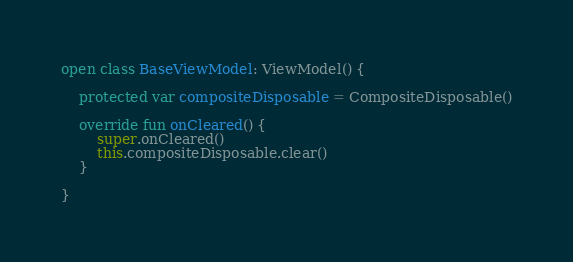Convert code to text. <code><loc_0><loc_0><loc_500><loc_500><_Kotlin_>open class BaseViewModel: ViewModel() {

    protected var compositeDisposable = CompositeDisposable()

    override fun onCleared() {
        super.onCleared()
        this.compositeDisposable.clear()
    }

}</code> 